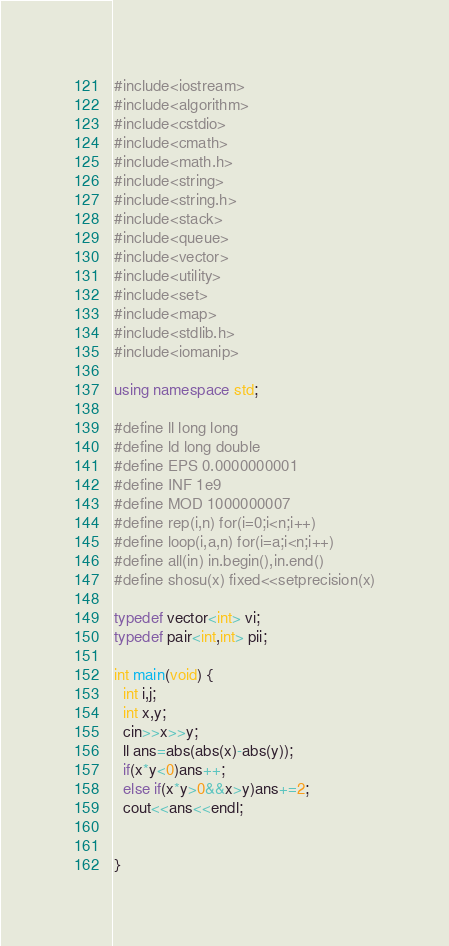Convert code to text. <code><loc_0><loc_0><loc_500><loc_500><_C++_>#include<iostream>
#include<algorithm>
#include<cstdio>
#include<cmath>
#include<math.h>
#include<string>
#include<string.h>
#include<stack>
#include<queue>
#include<vector>
#include<utility>
#include<set>
#include<map>
#include<stdlib.h>
#include<iomanip>

using namespace std;

#define ll long long
#define ld long double
#define EPS 0.0000000001
#define INF 1e9
#define MOD 1000000007
#define rep(i,n) for(i=0;i<n;i++)
#define loop(i,a,n) for(i=a;i<n;i++)
#define all(in) in.begin(),in.end()
#define shosu(x) fixed<<setprecision(x)

typedef vector<int> vi;
typedef pair<int,int> pii;

int main(void) {
  int i,j;
  int x,y;
  cin>>x>>y;
  ll ans=abs(abs(x)-abs(y));
  if(x*y<0)ans++;
  else if(x*y>0&&x>y)ans+=2;
  cout<<ans<<endl;


}
</code> 